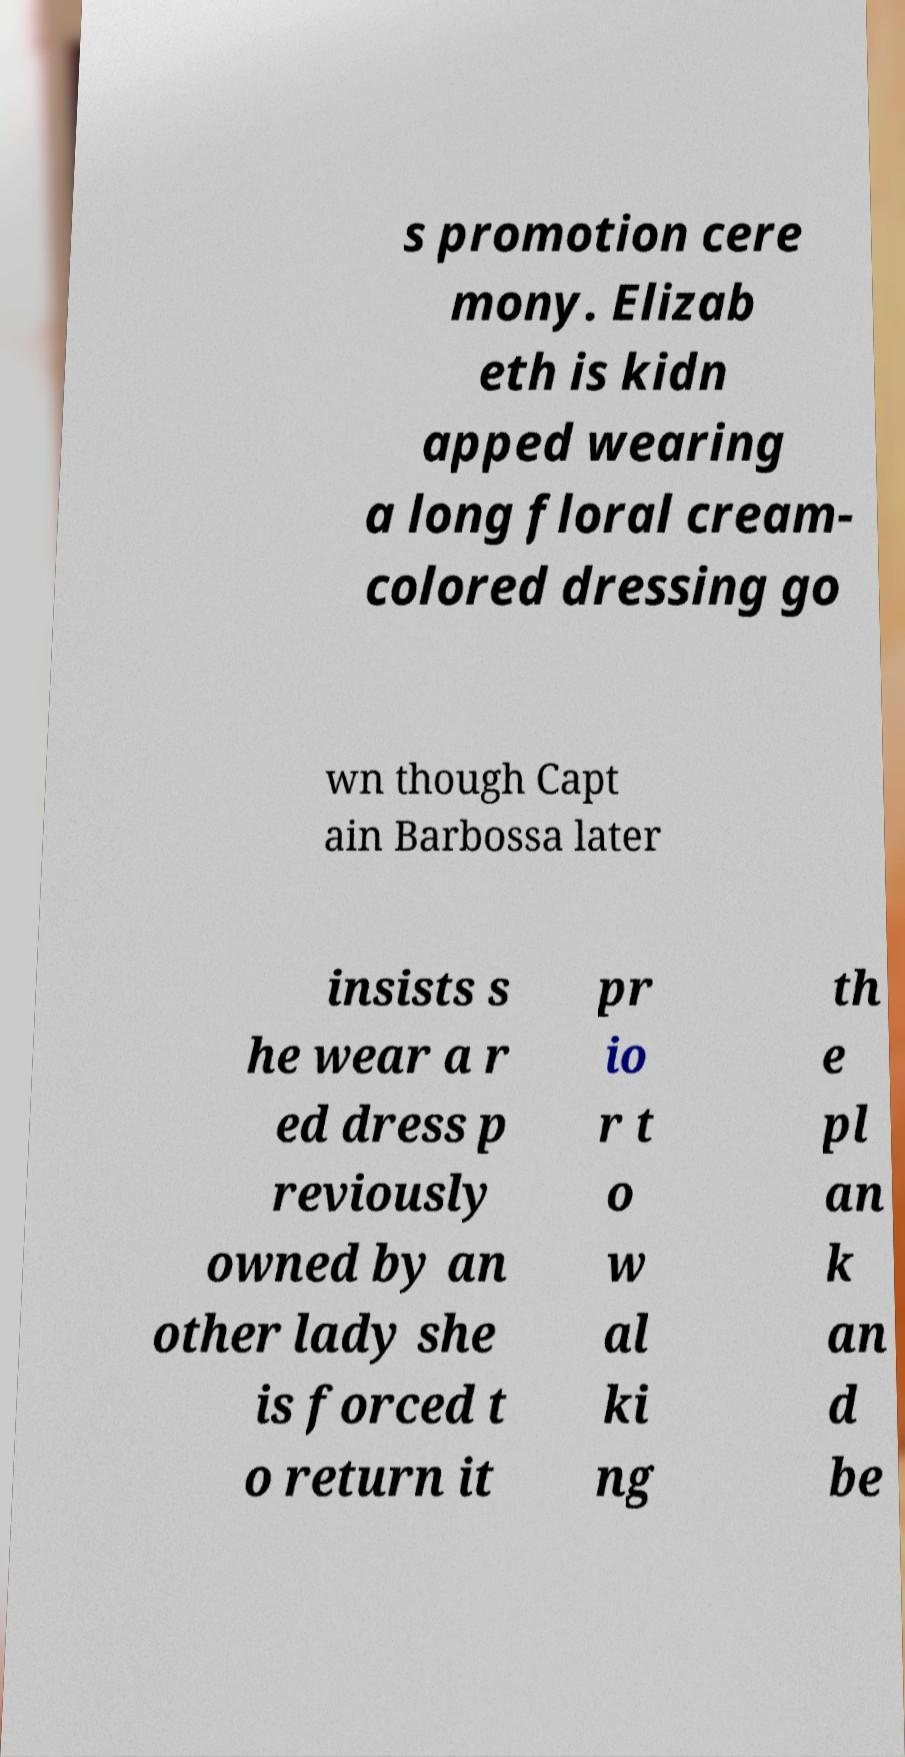What messages or text are displayed in this image? I need them in a readable, typed format. s promotion cere mony. Elizab eth is kidn apped wearing a long floral cream- colored dressing go wn though Capt ain Barbossa later insists s he wear a r ed dress p reviously owned by an other lady she is forced t o return it pr io r t o w al ki ng th e pl an k an d be 